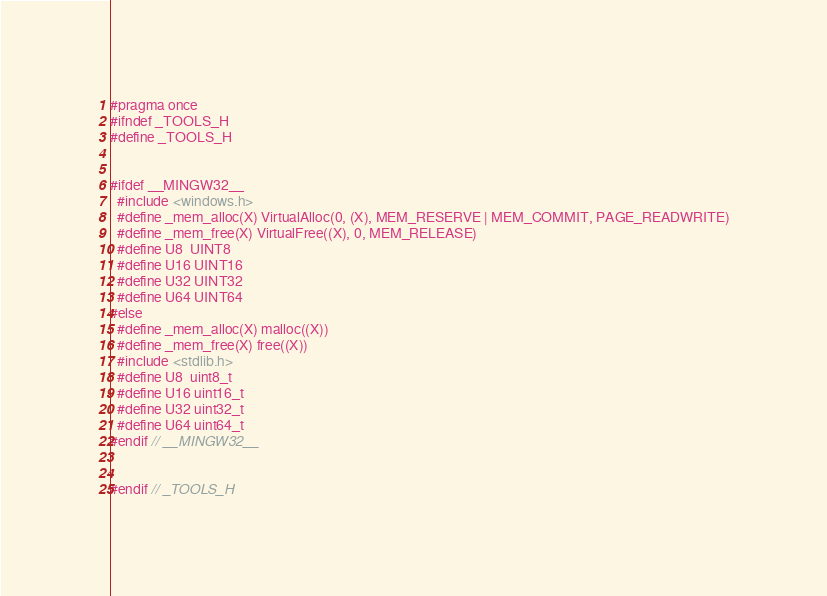Convert code to text. <code><loc_0><loc_0><loc_500><loc_500><_C_>#pragma once
#ifndef _TOOLS_H
#define _TOOLS_H


#ifdef __MINGW32__
  #include <windows.h>
  #define _mem_alloc(X) VirtualAlloc(0, (X), MEM_RESERVE | MEM_COMMIT, PAGE_READWRITE)
  #define _mem_free(X) VirtualFree((X), 0, MEM_RELEASE)
  #define U8  UINT8
  #define U16 UINT16
  #define U32 UINT32
  #define U64 UINT64
#else
  #define _mem_alloc(X) malloc((X))
  #define _mem_free(X) free((X))
  #include <stdlib.h>
  #define U8  uint8_t
  #define U16 uint16_t
  #define U32 uint32_t
  #define U64 uint64_t
#endif // __MINGW32__


#endif // _TOOLS_H
</code> 